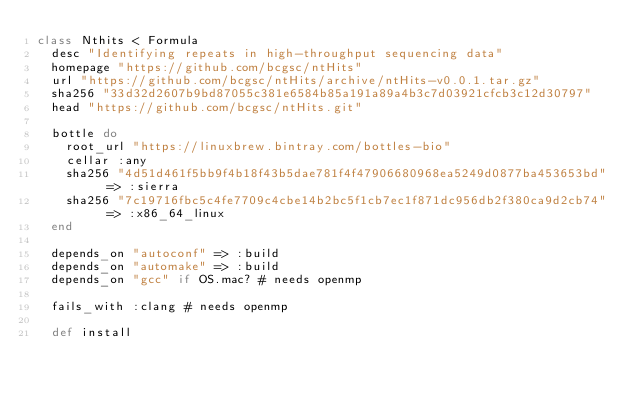<code> <loc_0><loc_0><loc_500><loc_500><_Ruby_>class Nthits < Formula
  desc "Identifying repeats in high-throughput sequencing data"
  homepage "https://github.com/bcgsc/ntHits"
  url "https://github.com/bcgsc/ntHits/archive/ntHits-v0.0.1.tar.gz"
  sha256 "33d32d2607b9bd87055c381e6584b85a191a89a4b3c7d03921cfcb3c12d30797"
  head "https://github.com/bcgsc/ntHits.git"

  bottle do
    root_url "https://linuxbrew.bintray.com/bottles-bio"
    cellar :any
    sha256 "4d51d461f5bb9f4b18f43b5dae781f4f47906680968ea5249d0877ba453653bd" => :sierra
    sha256 "7c19716fbc5c4fe7709c4cbe14b2bc5f1cb7ec1f871dc956db2f380ca9d2cb74" => :x86_64_linux
  end

  depends_on "autoconf" => :build
  depends_on "automake" => :build
  depends_on "gcc" if OS.mac? # needs openmp

  fails_with :clang # needs openmp

  def install</code> 